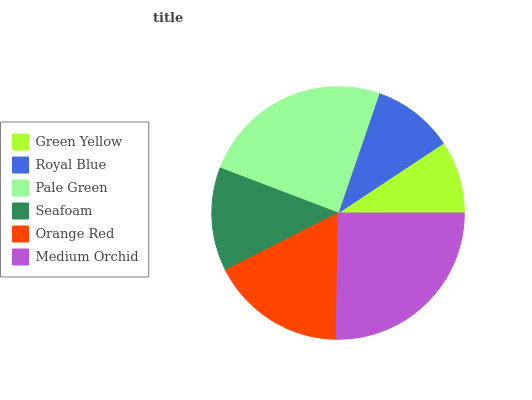Is Green Yellow the minimum?
Answer yes or no. Yes. Is Medium Orchid the maximum?
Answer yes or no. Yes. Is Royal Blue the minimum?
Answer yes or no. No. Is Royal Blue the maximum?
Answer yes or no. No. Is Royal Blue greater than Green Yellow?
Answer yes or no. Yes. Is Green Yellow less than Royal Blue?
Answer yes or no. Yes. Is Green Yellow greater than Royal Blue?
Answer yes or no. No. Is Royal Blue less than Green Yellow?
Answer yes or no. No. Is Orange Red the high median?
Answer yes or no. Yes. Is Seafoam the low median?
Answer yes or no. Yes. Is Medium Orchid the high median?
Answer yes or no. No. Is Orange Red the low median?
Answer yes or no. No. 